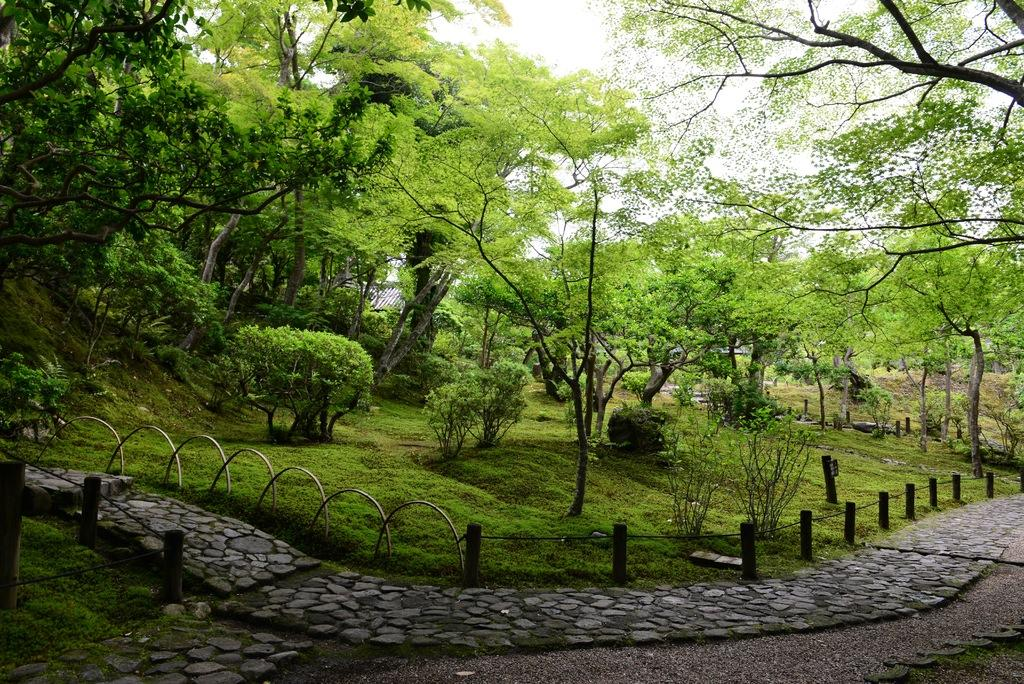What is located at the bottom of the image? There is a path and a fence at the bottom of the image. What type of vegetation can be seen in the background of the image? There is grass and trees in the background of the image. What part of the natural environment is visible in the image? The sky is visible in the background of the image. What type of stitch is being used to sew the church in the image? There is no church present in the image, and therefore no stitching can be observed. How does the stomach of the tree in the image appear? There are no trees with stomachs in the image; trees do not have stomachs. 